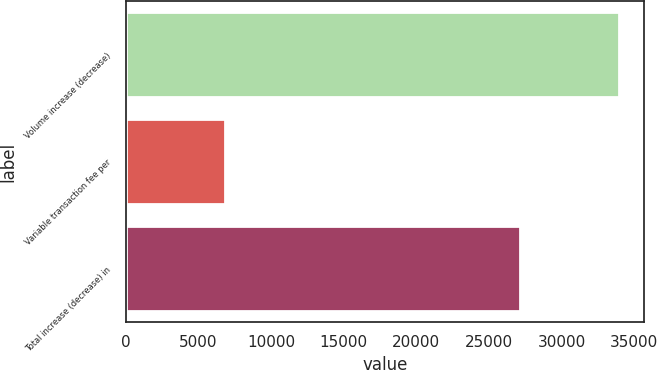Convert chart to OTSL. <chart><loc_0><loc_0><loc_500><loc_500><bar_chart><fcel>Volume increase (decrease)<fcel>Variable transaction fee per<fcel>Total increase (decrease) in<nl><fcel>33993<fcel>6853<fcel>27140<nl></chart> 